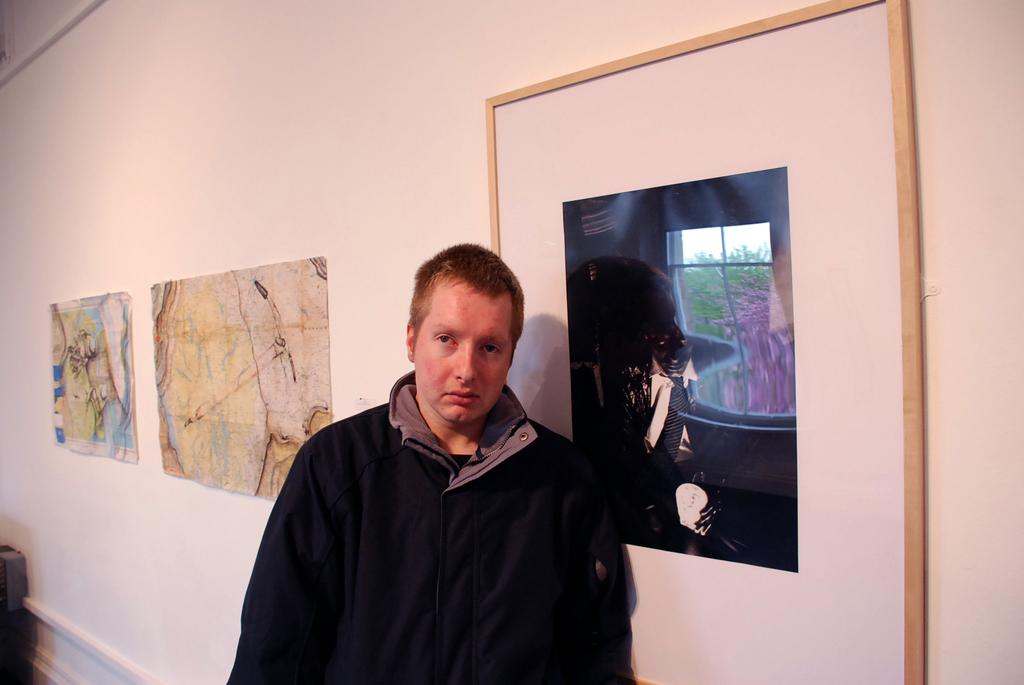What is the main subject in the image? There is a man standing in the image. What can be seen on the wall in the image? There are photo frames attached to the wall in the image. Can you describe the object in the bottom left corner of the image? Unfortunately, the provided facts do not give enough information to describe the object in the bottom left corner of the image. What type of linen is being used as a tablecloth in the image? There is no table or tablecloth present in the image, so it is not possible to determine the type of linen being used. 